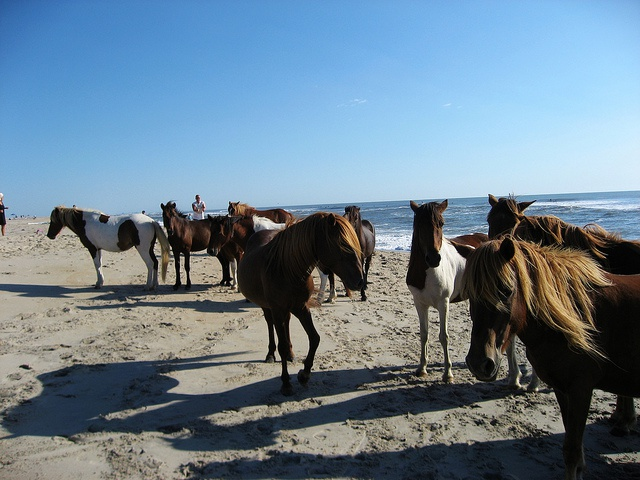Describe the objects in this image and their specific colors. I can see horse in blue, black, maroon, and tan tones, horse in blue, black, maroon, and gray tones, horse in blue, black, lightgray, and gray tones, horse in blue, black, gray, and maroon tones, and horse in blue, black, gray, darkgray, and darkgreen tones in this image. 